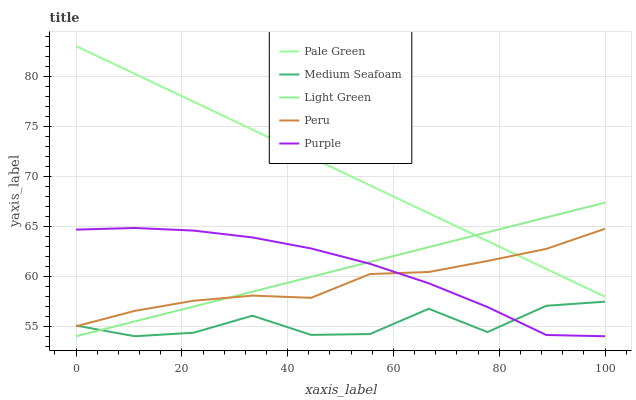Does Medium Seafoam have the minimum area under the curve?
Answer yes or no. Yes. Does Pale Green have the maximum area under the curve?
Answer yes or no. Yes. Does Peru have the minimum area under the curve?
Answer yes or no. No. Does Peru have the maximum area under the curve?
Answer yes or no. No. Is Light Green the smoothest?
Answer yes or no. Yes. Is Medium Seafoam the roughest?
Answer yes or no. Yes. Is Peru the smoothest?
Answer yes or no. No. Is Peru the roughest?
Answer yes or no. No. Does Purple have the lowest value?
Answer yes or no. Yes. Does Peru have the lowest value?
Answer yes or no. No. Does Pale Green have the highest value?
Answer yes or no. Yes. Does Peru have the highest value?
Answer yes or no. No. Is Purple less than Pale Green?
Answer yes or no. Yes. Is Pale Green greater than Medium Seafoam?
Answer yes or no. Yes. Does Medium Seafoam intersect Peru?
Answer yes or no. Yes. Is Medium Seafoam less than Peru?
Answer yes or no. No. Is Medium Seafoam greater than Peru?
Answer yes or no. No. Does Purple intersect Pale Green?
Answer yes or no. No. 